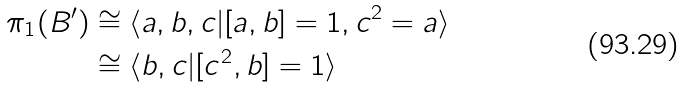Convert formula to latex. <formula><loc_0><loc_0><loc_500><loc_500>\pi _ { 1 } ( B ^ { \prime } ) & \cong \langle a , b , c | [ a , b ] = 1 , c ^ { 2 } = a \rangle \\ & \cong \langle b , c | [ c ^ { 2 } , b ] = 1 \rangle</formula> 